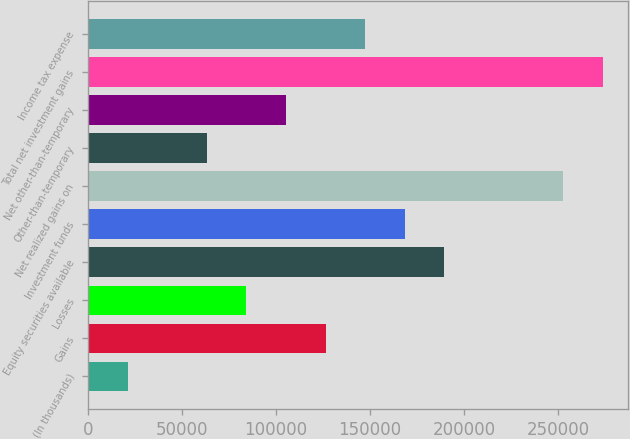Convert chart. <chart><loc_0><loc_0><loc_500><loc_500><bar_chart><fcel>(In thousands)<fcel>Gains<fcel>Losses<fcel>Equity securities available<fcel>Investment funds<fcel>Net realized gains on<fcel>Other-than-temporary<fcel>Net other-than-temporary<fcel>Total net investment gains<fcel>Income tax expense<nl><fcel>21115.8<fcel>126310<fcel>84232.2<fcel>189426<fcel>168387<fcel>252543<fcel>63193.4<fcel>105271<fcel>273581<fcel>147349<nl></chart> 